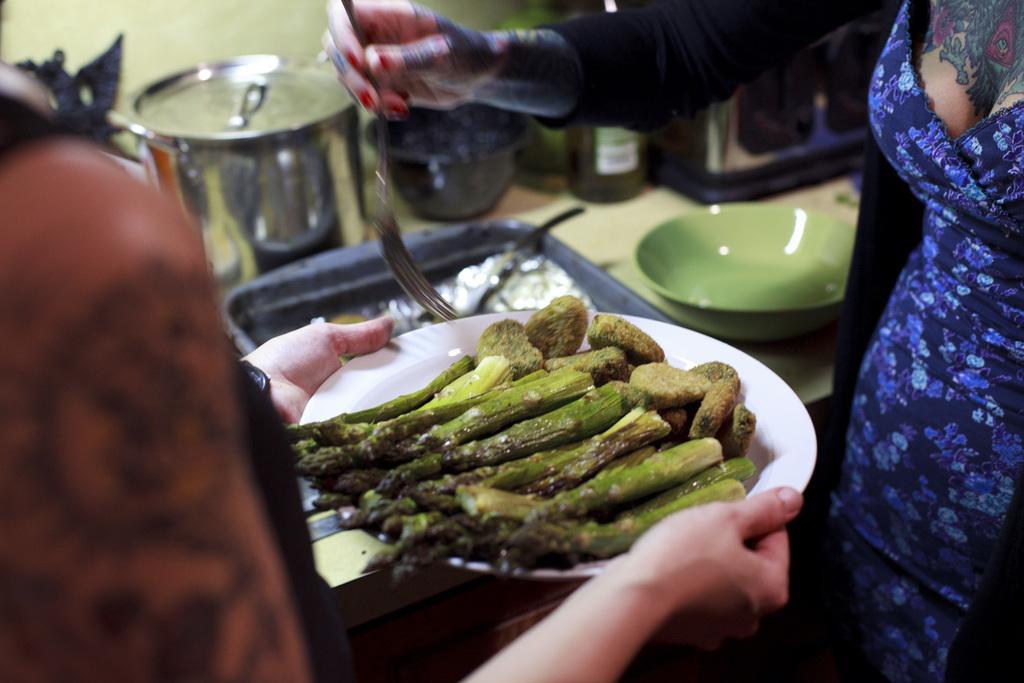How would you summarize this image in a sentence or two? In this image we can see some person holding the plate of food items. We can also see a woman on the right. In the background we can see a bowl, a tray and some vessels on the counter top. 